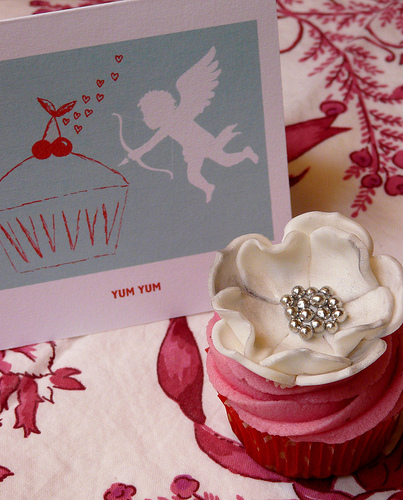<image>
Is there a beads on the flower? Yes. Looking at the image, I can see the beads is positioned on top of the flower, with the flower providing support. 